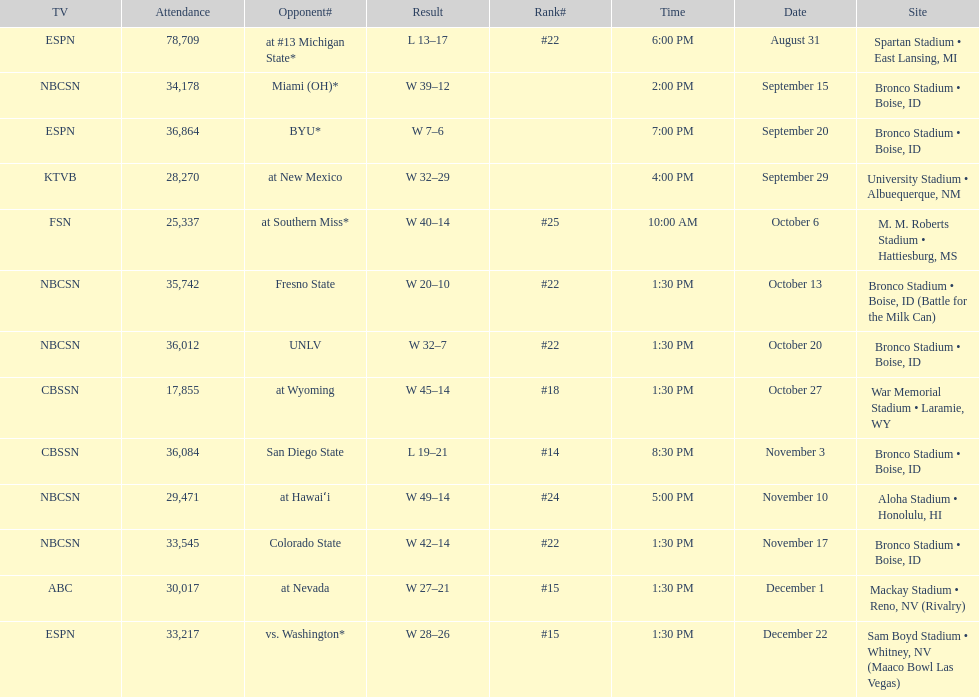What is the score difference for the game against michigan state? 4. 